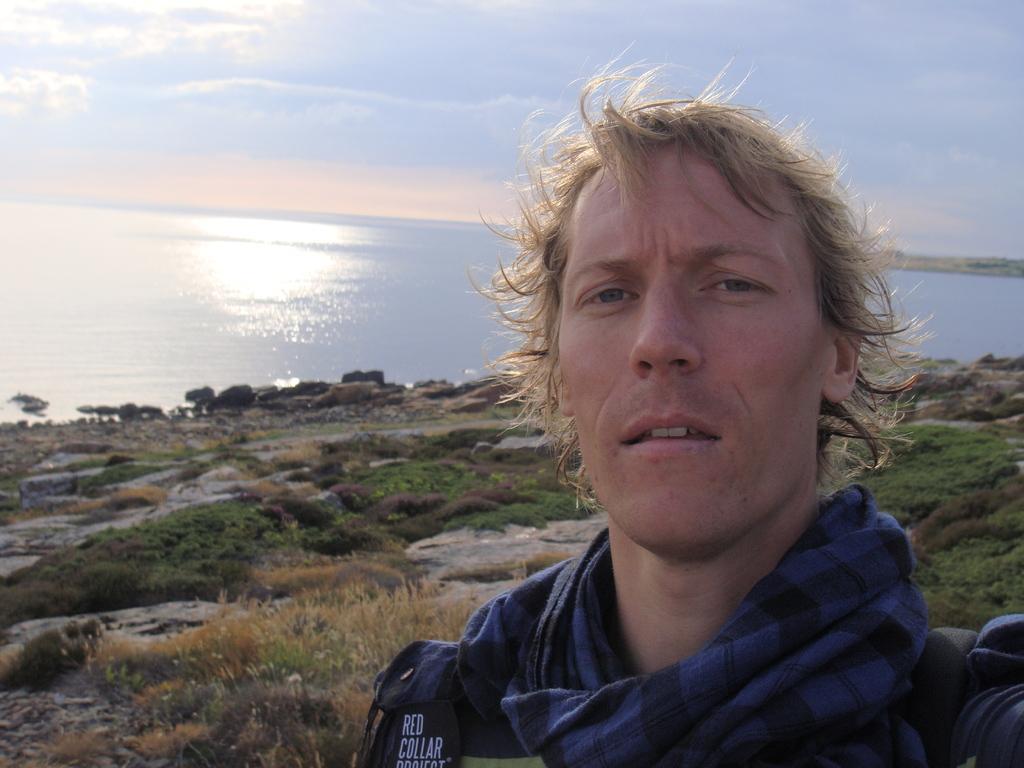Please provide a concise description of this image. This is man, these is grass and stones,this is water and sky. 